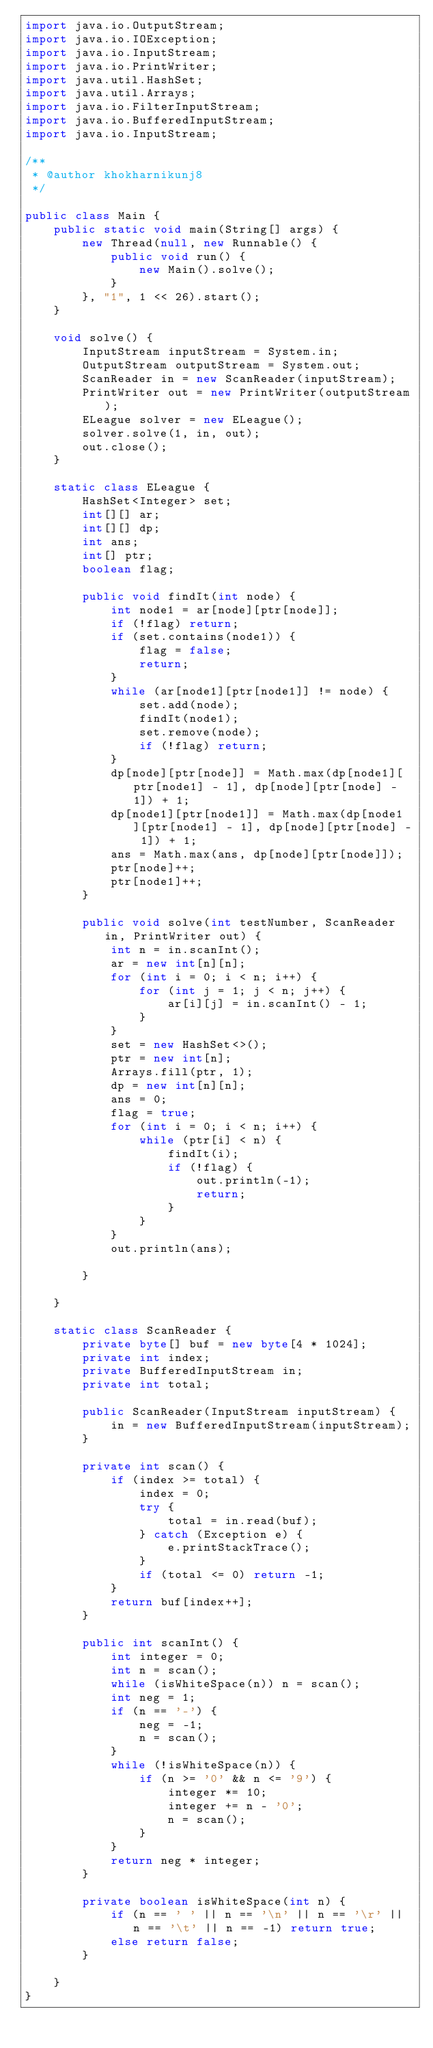Convert code to text. <code><loc_0><loc_0><loc_500><loc_500><_Java_>import java.io.OutputStream;
import java.io.IOException;
import java.io.InputStream;
import java.io.PrintWriter;
import java.util.HashSet;
import java.util.Arrays;
import java.io.FilterInputStream;
import java.io.BufferedInputStream;
import java.io.InputStream;

/**
 * @author khokharnikunj8
 */

public class Main {
    public static void main(String[] args) {
        new Thread(null, new Runnable() {
            public void run() {
                new Main().solve();
            }
        }, "1", 1 << 26).start();
    }

    void solve() {
        InputStream inputStream = System.in;
        OutputStream outputStream = System.out;
        ScanReader in = new ScanReader(inputStream);
        PrintWriter out = new PrintWriter(outputStream);
        ELeague solver = new ELeague();
        solver.solve(1, in, out);
        out.close();
    }

    static class ELeague {
        HashSet<Integer> set;
        int[][] ar;
        int[][] dp;
        int ans;
        int[] ptr;
        boolean flag;

        public void findIt(int node) {
            int node1 = ar[node][ptr[node]];
            if (!flag) return;
            if (set.contains(node1)) {
                flag = false;
                return;
            }
            while (ar[node1][ptr[node1]] != node) {
                set.add(node);
                findIt(node1);
                set.remove(node);
                if (!flag) return;
            }
            dp[node][ptr[node]] = Math.max(dp[node1][ptr[node1] - 1], dp[node][ptr[node] - 1]) + 1;
            dp[node1][ptr[node1]] = Math.max(dp[node1][ptr[node1] - 1], dp[node][ptr[node] - 1]) + 1;
            ans = Math.max(ans, dp[node][ptr[node]]);
            ptr[node]++;
            ptr[node1]++;
        }

        public void solve(int testNumber, ScanReader in, PrintWriter out) {
            int n = in.scanInt();
            ar = new int[n][n];
            for (int i = 0; i < n; i++) {
                for (int j = 1; j < n; j++) {
                    ar[i][j] = in.scanInt() - 1;
                }
            }
            set = new HashSet<>();
            ptr = new int[n];
            Arrays.fill(ptr, 1);
            dp = new int[n][n];
            ans = 0;
            flag = true;
            for (int i = 0; i < n; i++) {
                while (ptr[i] < n) {
                    findIt(i);
                    if (!flag) {
                        out.println(-1);
                        return;
                    }
                }
            }
            out.println(ans);

        }

    }

    static class ScanReader {
        private byte[] buf = new byte[4 * 1024];
        private int index;
        private BufferedInputStream in;
        private int total;

        public ScanReader(InputStream inputStream) {
            in = new BufferedInputStream(inputStream);
        }

        private int scan() {
            if (index >= total) {
                index = 0;
                try {
                    total = in.read(buf);
                } catch (Exception e) {
                    e.printStackTrace();
                }
                if (total <= 0) return -1;
            }
            return buf[index++];
        }

        public int scanInt() {
            int integer = 0;
            int n = scan();
            while (isWhiteSpace(n)) n = scan();
            int neg = 1;
            if (n == '-') {
                neg = -1;
                n = scan();
            }
            while (!isWhiteSpace(n)) {
                if (n >= '0' && n <= '9') {
                    integer *= 10;
                    integer += n - '0';
                    n = scan();
                }
            }
            return neg * integer;
        }

        private boolean isWhiteSpace(int n) {
            if (n == ' ' || n == '\n' || n == '\r' || n == '\t' || n == -1) return true;
            else return false;
        }

    }
}

</code> 